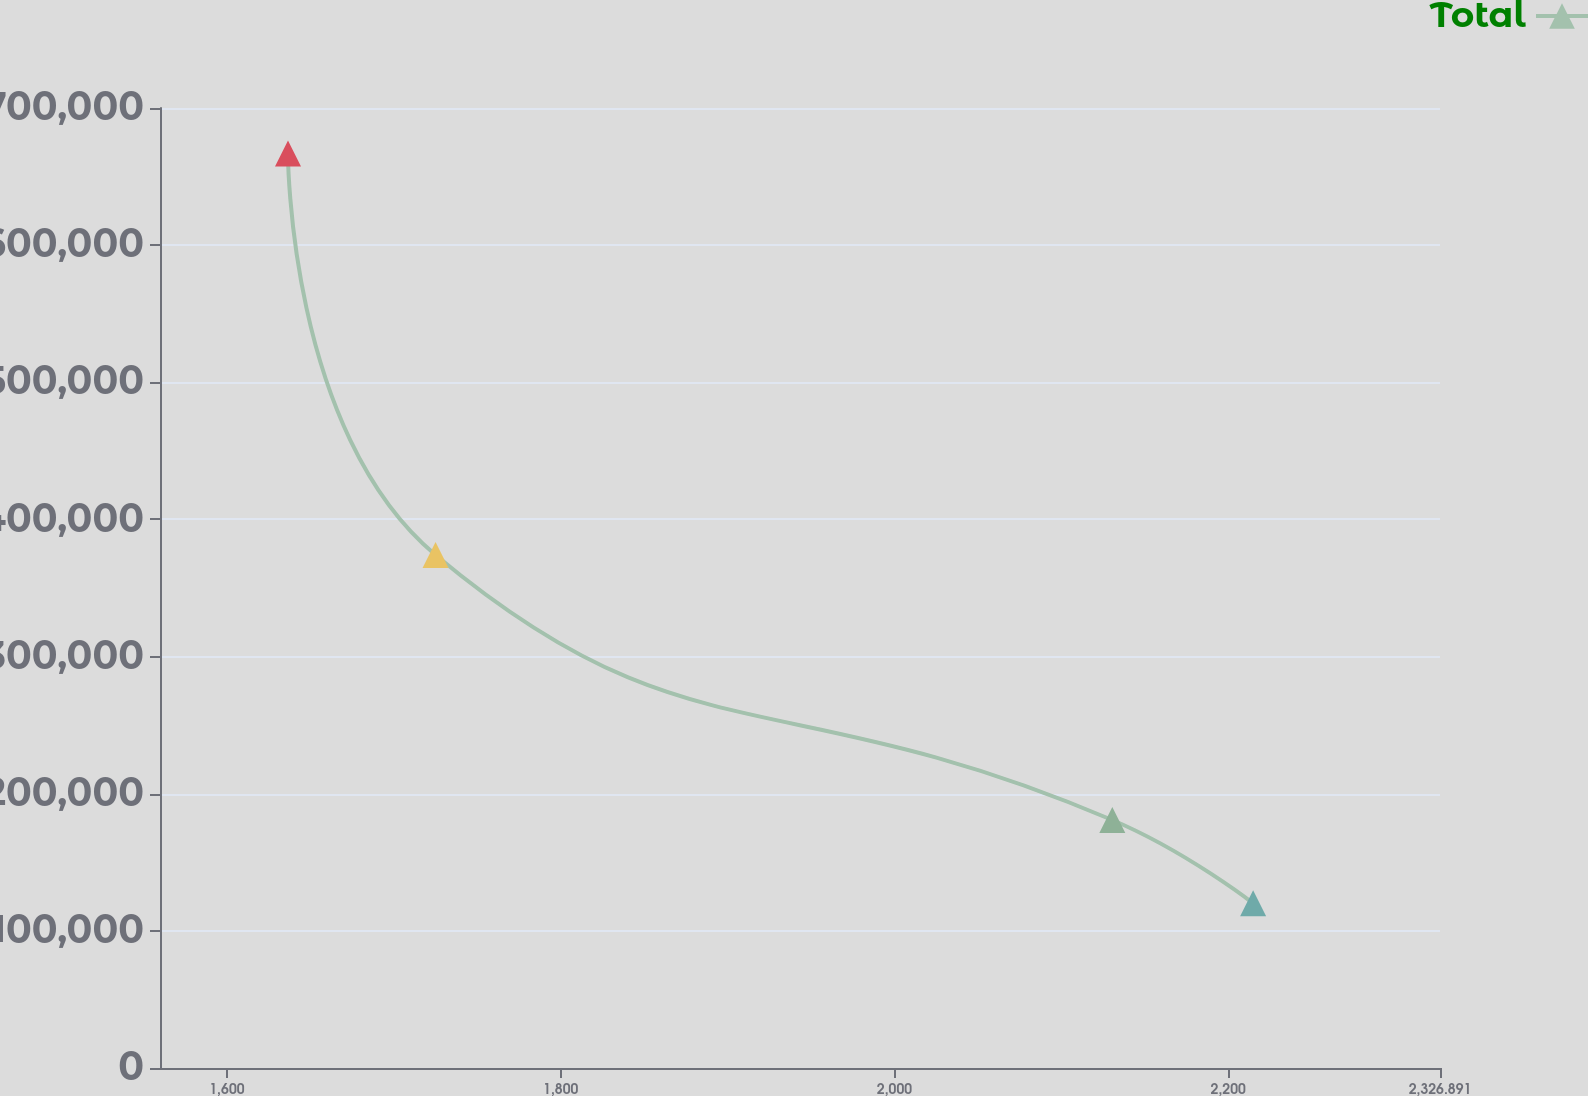Convert chart. <chart><loc_0><loc_0><loc_500><loc_500><line_chart><ecel><fcel>Total<nl><fcel>1636.6<fcel>666908<nl><fcel>1725.01<fcel>374121<nl><fcel>2130.52<fcel>180817<nl><fcel>2214.9<fcel>120056<nl><fcel>2403.59<fcel>59294.1<nl></chart> 